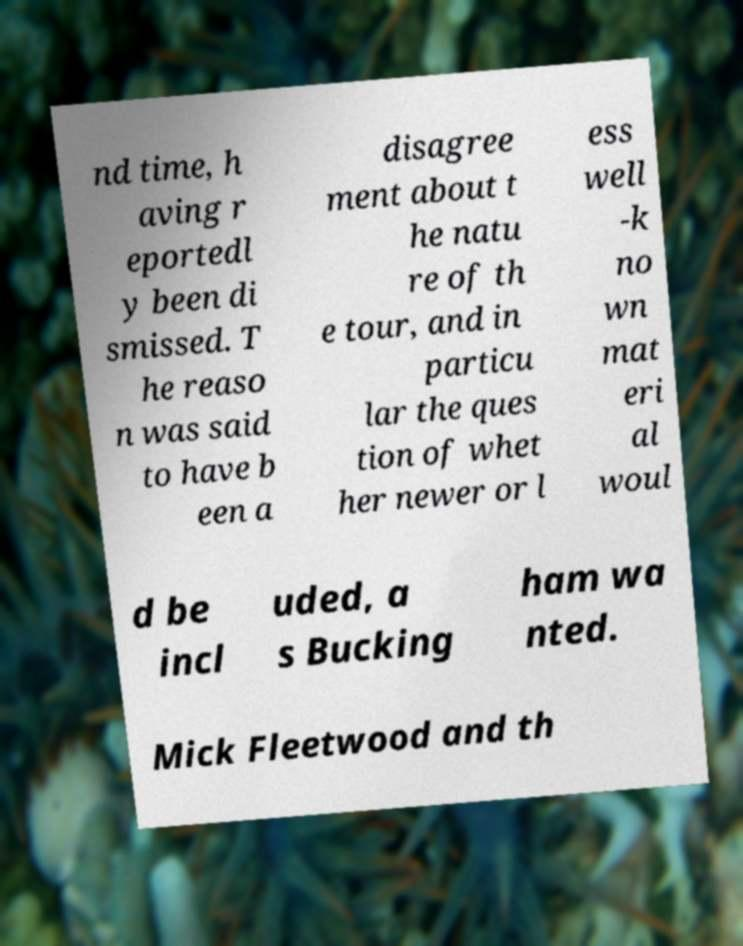Could you extract and type out the text from this image? nd time, h aving r eportedl y been di smissed. T he reaso n was said to have b een a disagree ment about t he natu re of th e tour, and in particu lar the ques tion of whet her newer or l ess well -k no wn mat eri al woul d be incl uded, a s Bucking ham wa nted. Mick Fleetwood and th 